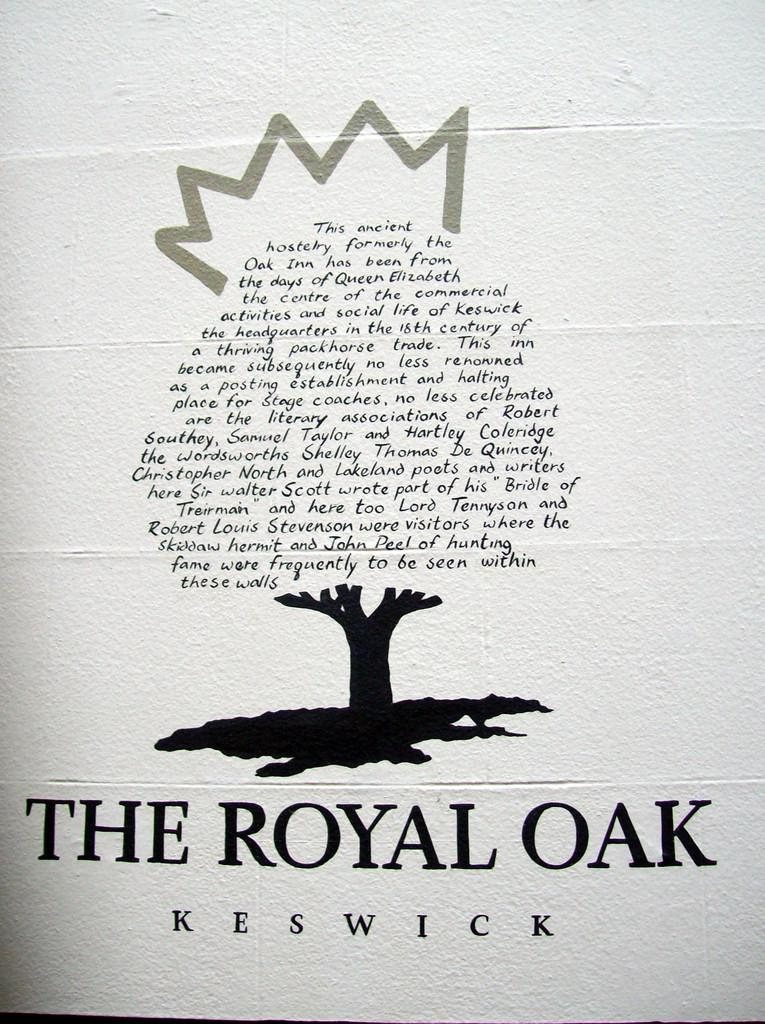<image>
Share a concise interpretation of the image provided. a page that says 'the royal oak keswick' at the bottom in bold lettering 